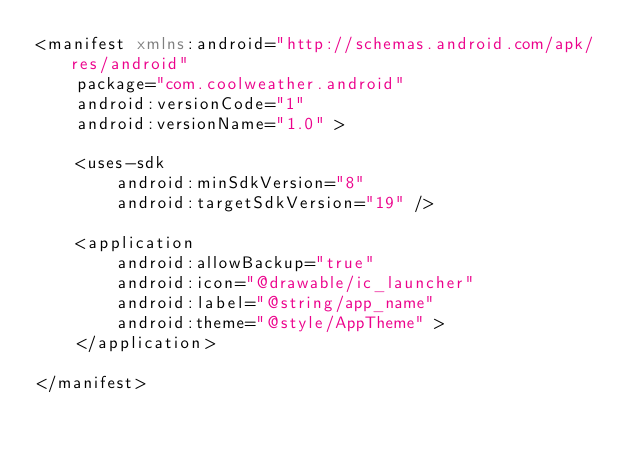<code> <loc_0><loc_0><loc_500><loc_500><_XML_><manifest xmlns:android="http://schemas.android.com/apk/res/android"
    package="com.coolweather.android"
    android:versionCode="1"
    android:versionName="1.0" >

    <uses-sdk
        android:minSdkVersion="8"
        android:targetSdkVersion="19" />

    <application
        android:allowBackup="true"
        android:icon="@drawable/ic_launcher"
        android:label="@string/app_name"
        android:theme="@style/AppTheme" >
    </application>

</manifest>
</code> 